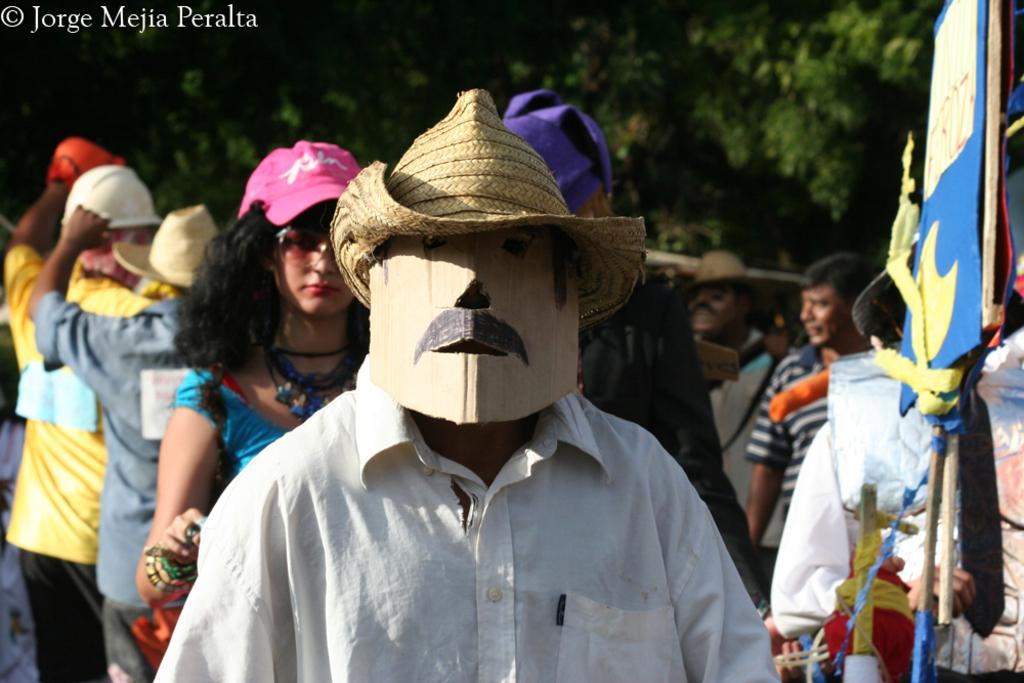What is happening in the image involving the group of people? The people in the image are walking. How can you describe the appearance of the people in the image? The people are wearing different color dresses, and one person in front is wearing a cardboard mask, while another is wearing a hat. What can be seen in the background of the image? There are trees and boards visible in the image. Is there a current or stream visible in the image? No, there is no current or stream visible in the image. How does the group of people wash their clothes in the image? There is no indication in the image that the group of people is washing clothes. 